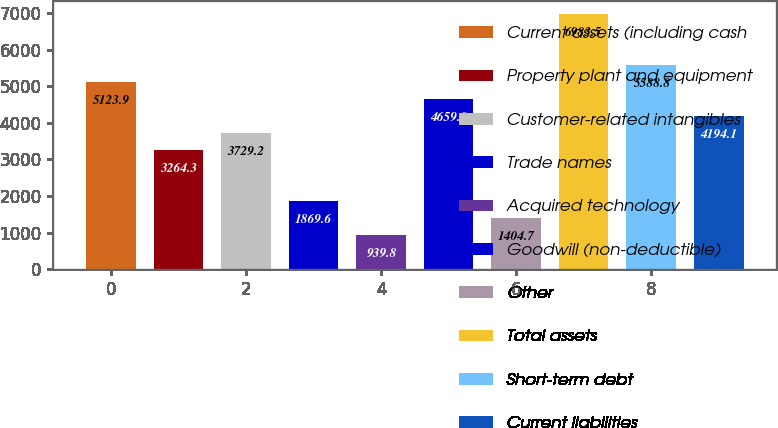Convert chart. <chart><loc_0><loc_0><loc_500><loc_500><bar_chart><fcel>Current assets (including cash<fcel>Property plant and equipment<fcel>Customer-related intangibles<fcel>Trade names<fcel>Acquired technology<fcel>Goodwill (non-deductible)<fcel>Other<fcel>Total assets<fcel>Short-term debt<fcel>Current liabilities<nl><fcel>5123.9<fcel>3264.3<fcel>3729.2<fcel>1869.6<fcel>939.8<fcel>4659<fcel>1404.7<fcel>6983.5<fcel>5588.8<fcel>4194.1<nl></chart> 